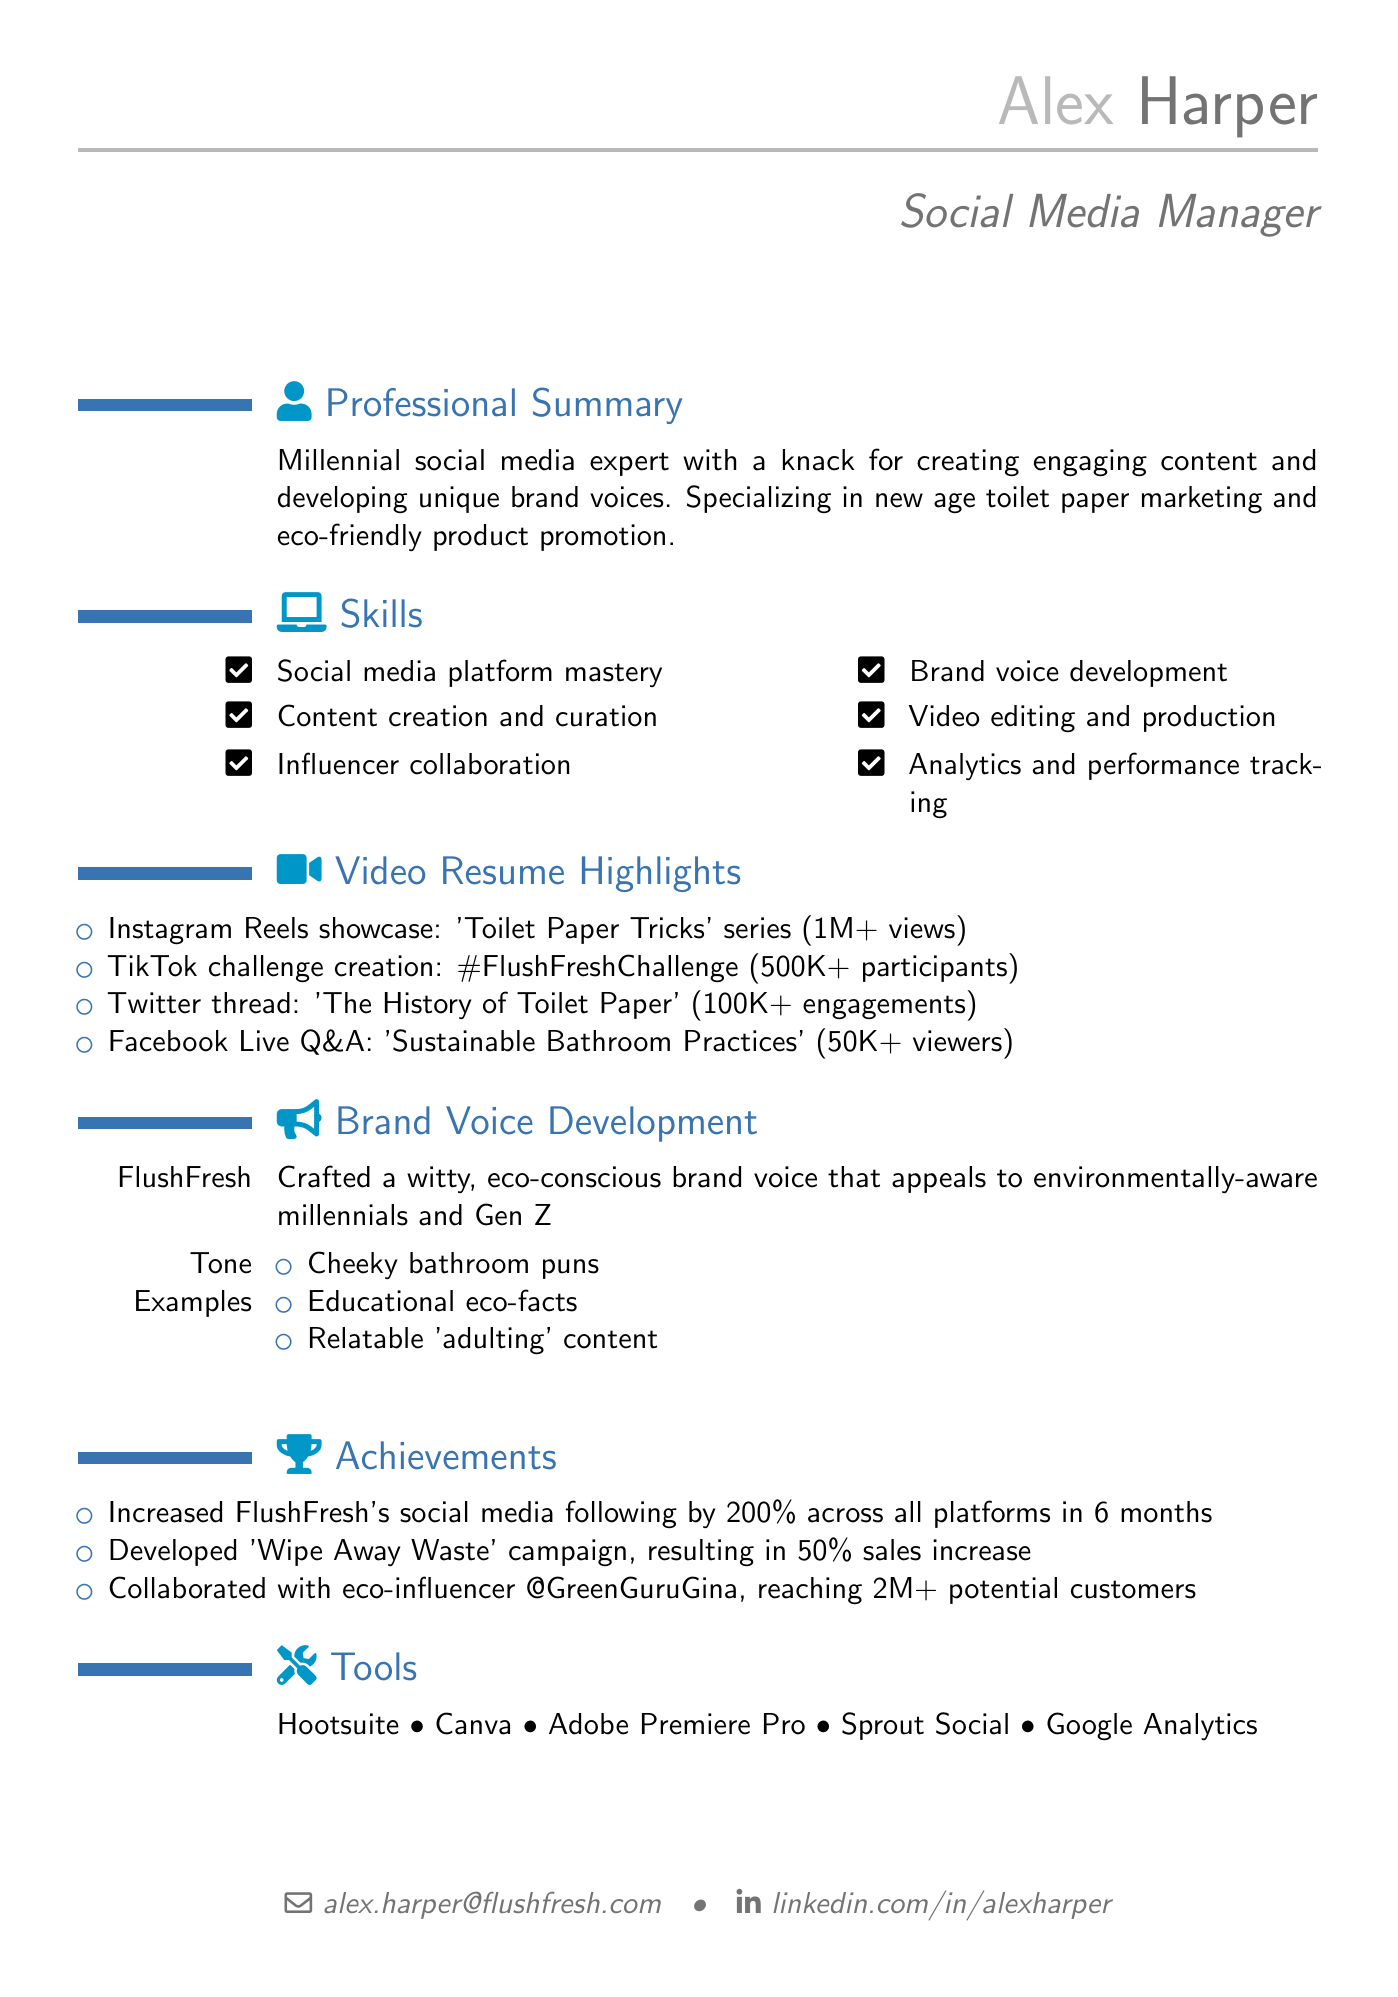What is Alex Harper's email address? The email address can be found in the personal information section of the document.
Answer: alex.harper@flushfresh.com How much did FlushFresh increase its social media following? The increase in social media following is stated in the achievements section of the document.
Answer: 200% What is the title of the video resume highlights? The title refers to the video resume section and summarizes major achievements in social media.
Answer: Video Resume Highlights What was the result of the 'Wipe Away Waste' campaign? The achievement corresponding to this campaign detail explains its impact on sales.
Answer: 50% sales increase Which social media platform had the most views in the highlights? This can be deduced from the views reported for each platform in the video resume highlights.
Answer: Instagram Reels What type of brand voice was developed for FlushFresh? This information is derived from the brand voice development section describing the tone.
Answer: Witty, eco-conscious How many participants were in the #FlushFreshChallenge? The number of participants is listed under the TikTok challenge creation highlight.
Answer: 500K+ What tools does Alex Harper use? The tools section lists multiple tools used for social media management and content creation.
Answer: Hootsuite, Canva, Adobe Premiere Pro, Sprout Social, Google Analytics 